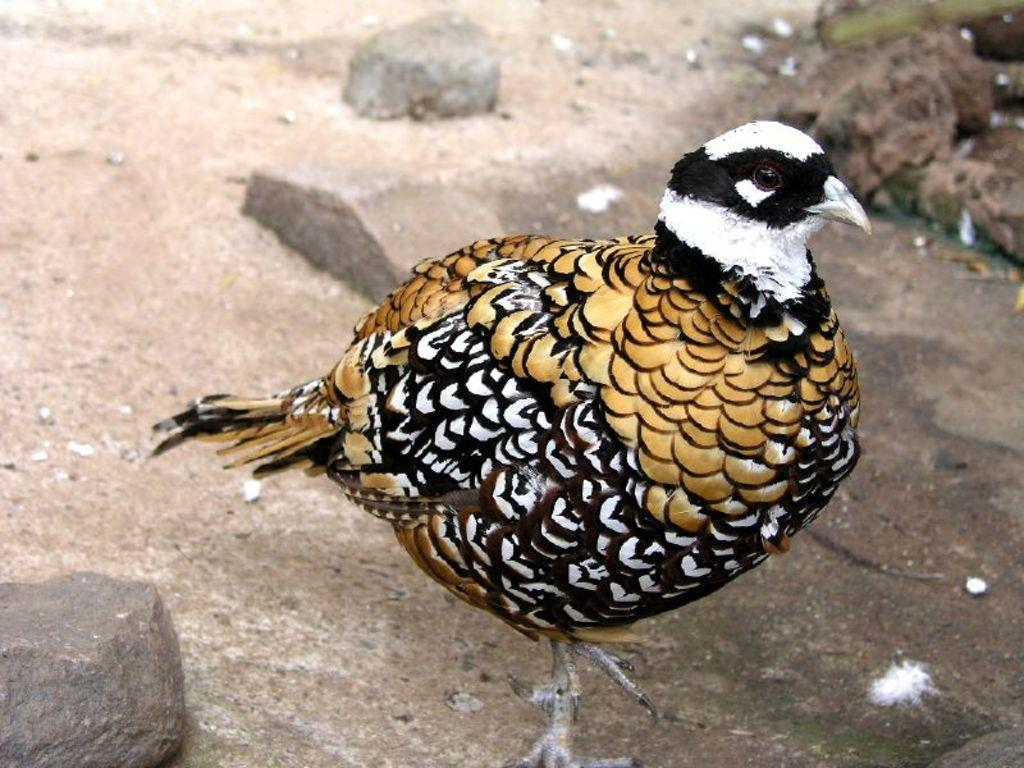What type of animal can be seen in the picture? There is a bird in the picture. What else can be seen in the picture besides the bird? There are stones visible in the picture. What type of calculator is being used by the bird in the picture? There is no calculator present in the picture; it only features a bird and stones. 